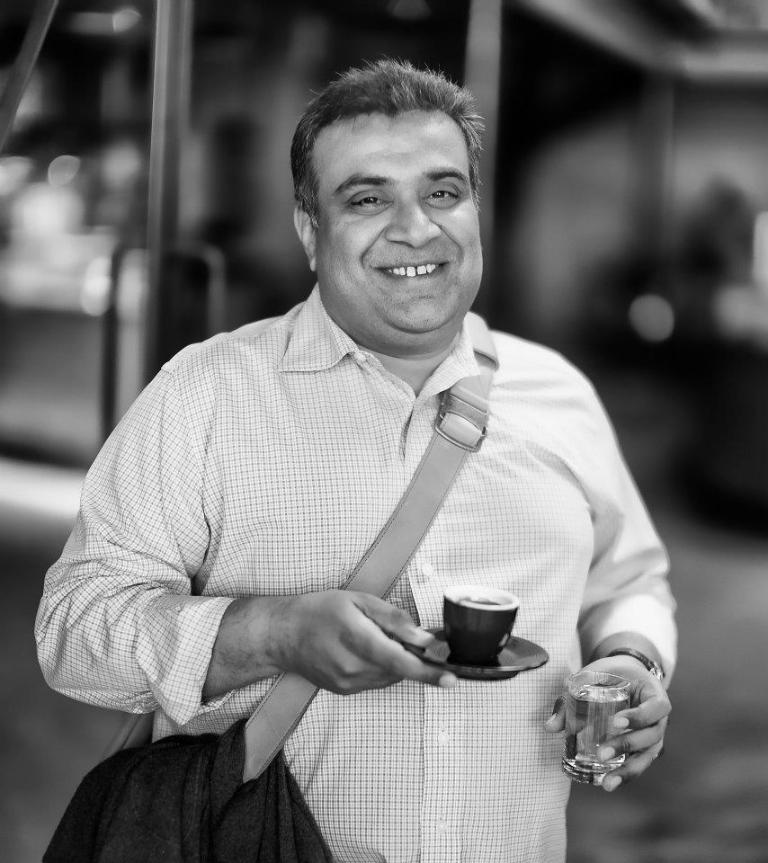Who is present in the image? There is a man in the image. What is the man doing in the image? The man is standing in the image. What objects is the man holding in the image? The man is holding a glass and a cup in the image. What is the color scheme of the image? The image is in black and white color. What type of question is the dog asking in the image? There is no dog present in the image, and therefore no such question can be observed. 